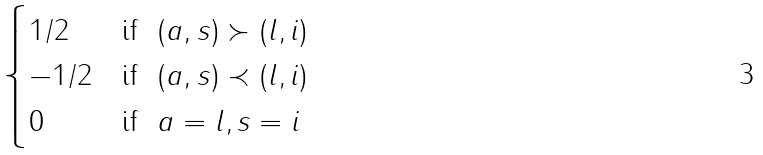Convert formula to latex. <formula><loc_0><loc_0><loc_500><loc_500>\begin{cases} 1 / 2 & \text {if} \ \ ( a , s ) \succ ( l , i ) \\ - 1 / 2 & \text {if} \ \ ( a , s ) \prec ( l , i ) \\ 0 & \text {if} \ \ a = l , s = i \end{cases}</formula> 